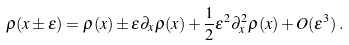Convert formula to latex. <formula><loc_0><loc_0><loc_500><loc_500>\rho ( x \pm \varepsilon ) = \rho ( x ) \pm \varepsilon \partial _ { x } \rho ( x ) + \frac { 1 } { 2 } \varepsilon ^ { 2 } \partial ^ { 2 } _ { x } \rho ( x ) + O ( \varepsilon ^ { 3 } ) \, .</formula> 